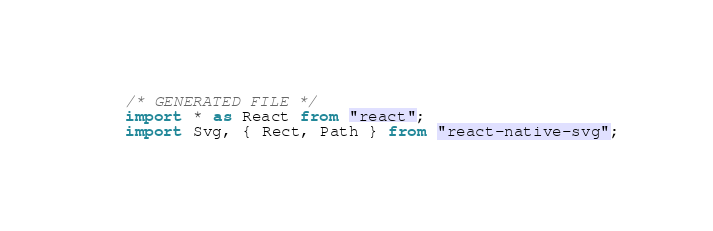Convert code to text. <code><loc_0><loc_0><loc_500><loc_500><_TypeScript_>/* GENERATED FILE */
import * as React from "react";
import Svg, { Rect, Path } from "react-native-svg";
</code> 